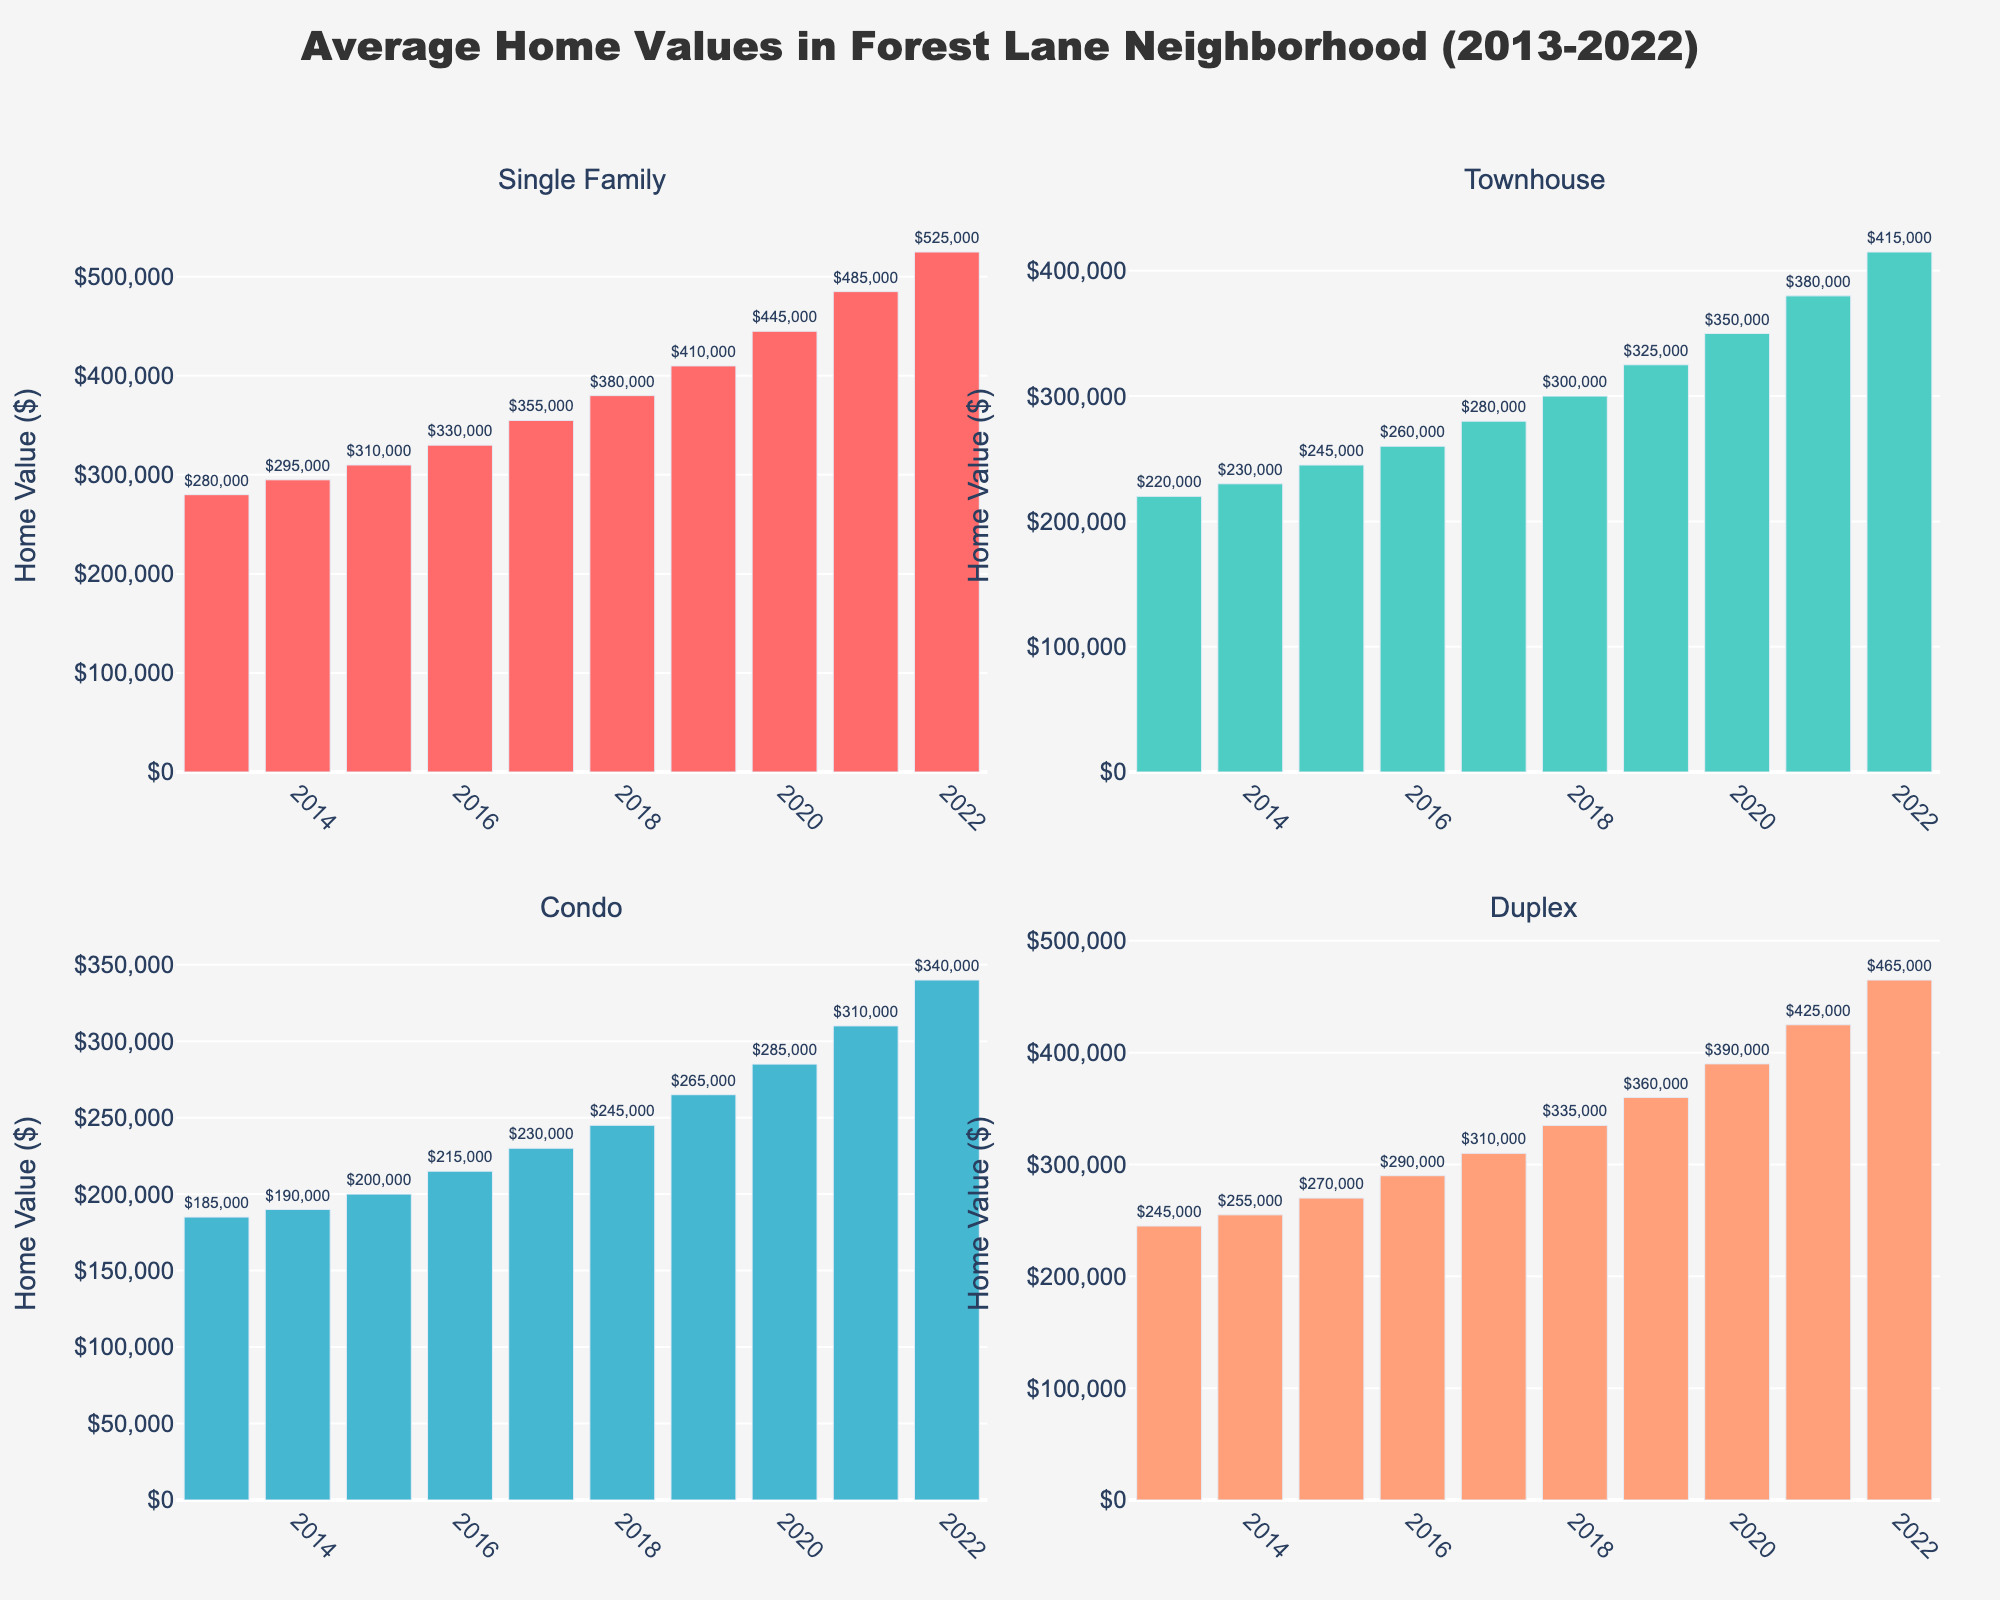What is the title of the subplot of pie charts? The title of the subplot is typically found at the top, usually in a larger or bold font to signify its importance. From the provided code, the title is defined as "Distribution of Body Modification Types Across Studios".
Answer: Distribution of Body Modification Types Across Studios Which studio has the highest percentage of tattoos? By examining the pie chart corresponding to tattoos, you can compare the percentages of each studio. Dark Arts Tattoo has the highest percentage, covering 55% of the pie chart for tattoos.
Answer: Dark Arts Tattoo How many studios offer scarification services? In the pie chart related to scarification, the studios offering this service will have a slice in the pie. Count the number of slices to determine the number of studios. There are five studios: Ink Addicts, Mod Squad, Dark Arts Tattoo, Body Evolution, and The Modification Shop.
Answer: Five Which body modification type shows the largest variation in percentage across studios? Compare the variances in the sizes of slices in each pie chart. Piercings show a large variance because, for some studios like The Piercing Emporium and Piercing Paradise, the percentage is very high, while for others, it is significantly lower.
Answer: Piercings Which studio offers the least number of different body modification types? Look for the studio with the least variety in slices across all pie charts. Piercing Paradise and The Piercing Emporium offer the fewest different types, focusing heavily on piercings.
Answer: Piercing Paradise and The Piercing Emporium What percentage of microdermals is offered by Body Evolution? Find the pie chart for microdermals. Body Evolution's slice in this chart represents 12% of the total services offered.
Answer: 12% Which service does Mod Squad offer more than Ink Addicts? Compare the sizes of the slices for the two studios across all pie charts. For piercings and scarification, Mod Squad offers more (35% and 10% respectively) compared to Ink Addicts (30% and 5% respectively).
Answer: Piercings and Scarification Compare the total offerings of The Piercing Emporium and Skin Deep Studio in terms of diversity. Which offers more types? Count the different types of body modifications each studio offers. The Piercing Emporium offers piercings, microdermals, and tongue splitting. Skin Deep Studio offers tattoos, piercings, scarification, branding, microdermals, and tongue splitting. Skin Deep Studio offers a wider variety.
Answer: Skin Deep Studio What is the combined percentage of ear pointing services offered by Mod Squad and Skin Deep Studio? Add the percentages from the pie chart for ear pointing corresponding to both studios (3% from Mod Squad and 3% from Skin Deep Studio). The combined percentage is 6%.
Answer: 6% 